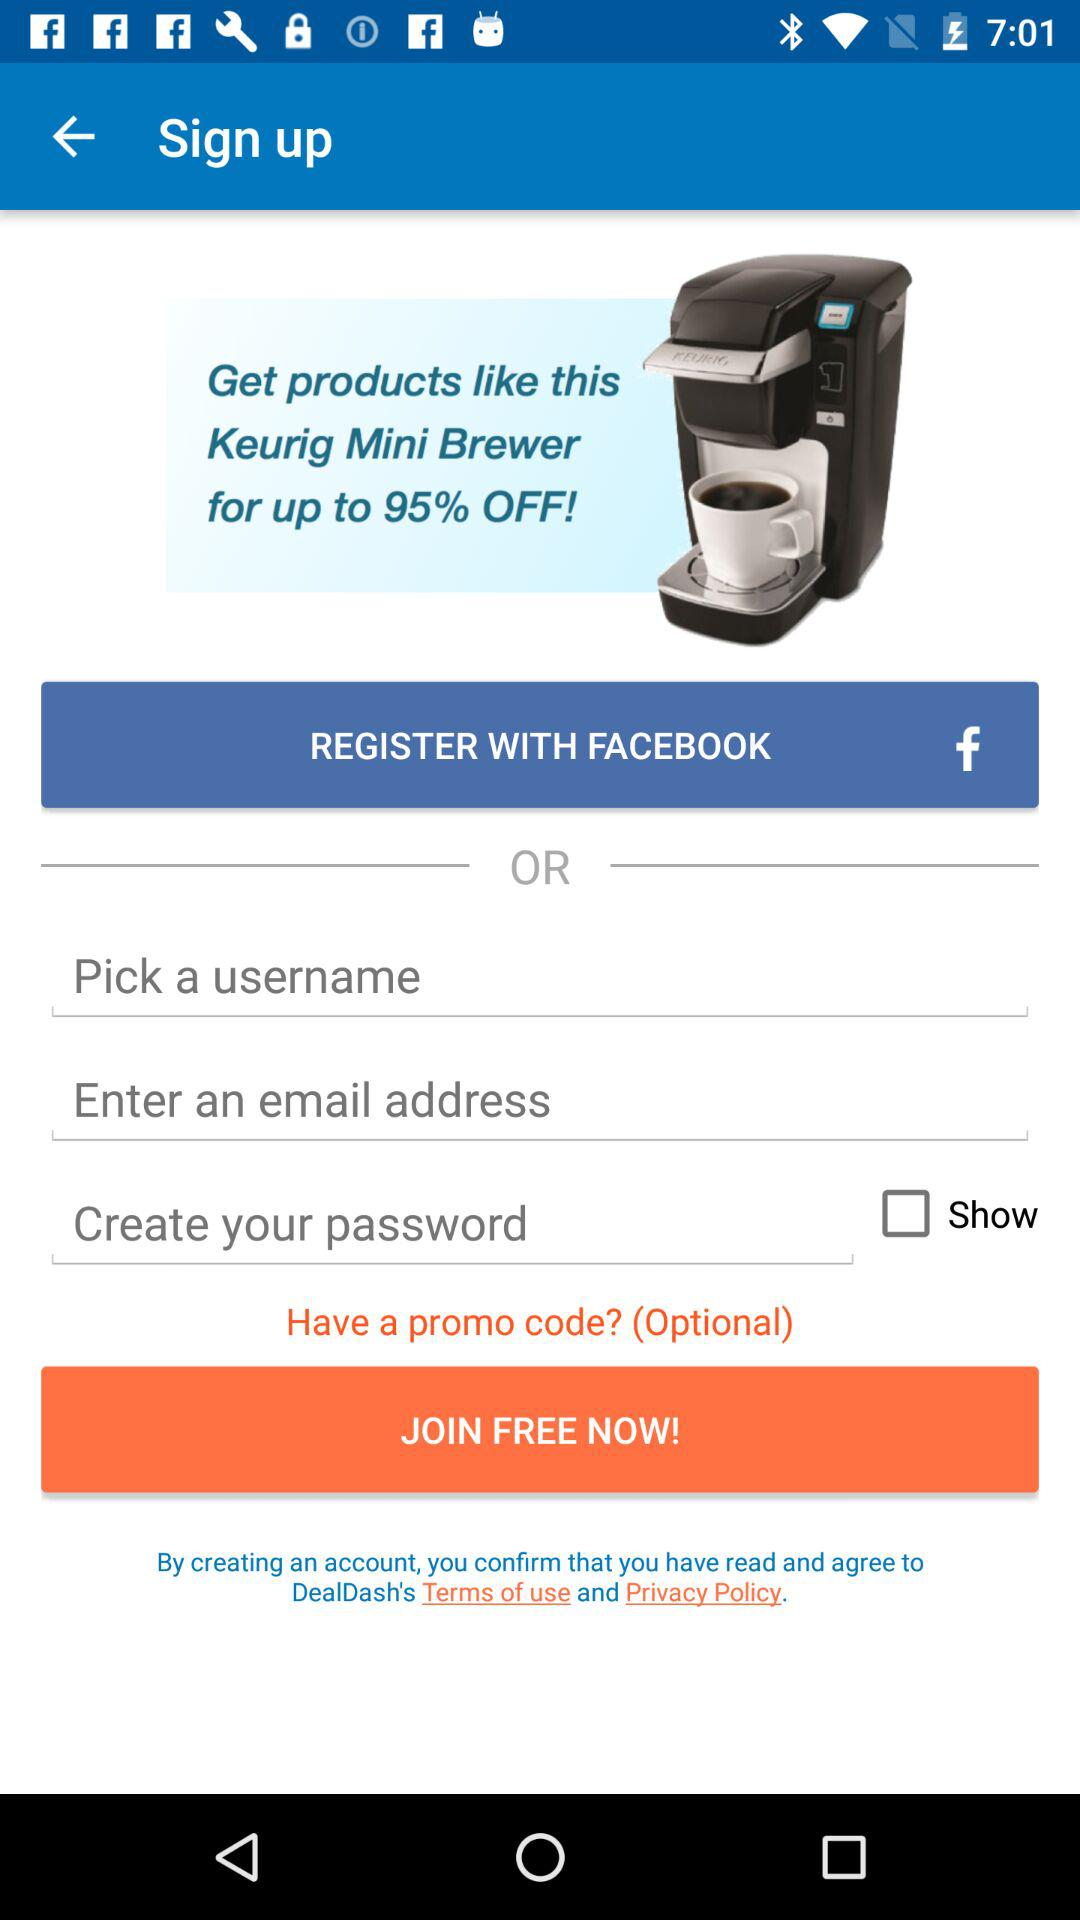With which account can the user register? The user can register with "Facebook" and "Email" accounts. 